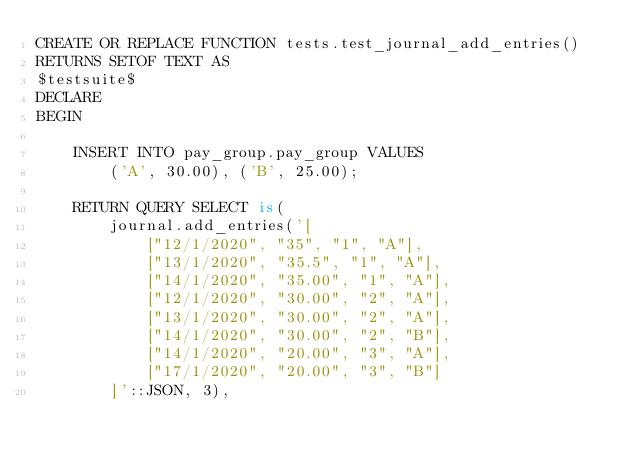<code> <loc_0><loc_0><loc_500><loc_500><_SQL_>CREATE OR REPLACE FUNCTION tests.test_journal_add_entries()
RETURNS SETOF TEXT AS
$testsuite$
DECLARE
BEGIN

    INSERT INTO pay_group.pay_group VALUES
        ('A', 30.00), ('B', 25.00);

    RETURN QUERY SELECT is(
        journal.add_entries('[
            ["12/1/2020", "35", "1", "A"],
            ["13/1/2020", "35.5", "1", "A"],
            ["14/1/2020", "35.00", "1", "A"],
            ["12/1/2020", "30.00", "2", "A"],
            ["13/1/2020", "30.00", "2", "A"],
            ["14/1/2020", "30.00", "2", "B"],
            ["14/1/2020", "20.00", "3", "A"],
            ["17/1/2020", "20.00", "3", "B"]
        ]'::JSON, 3),</code> 